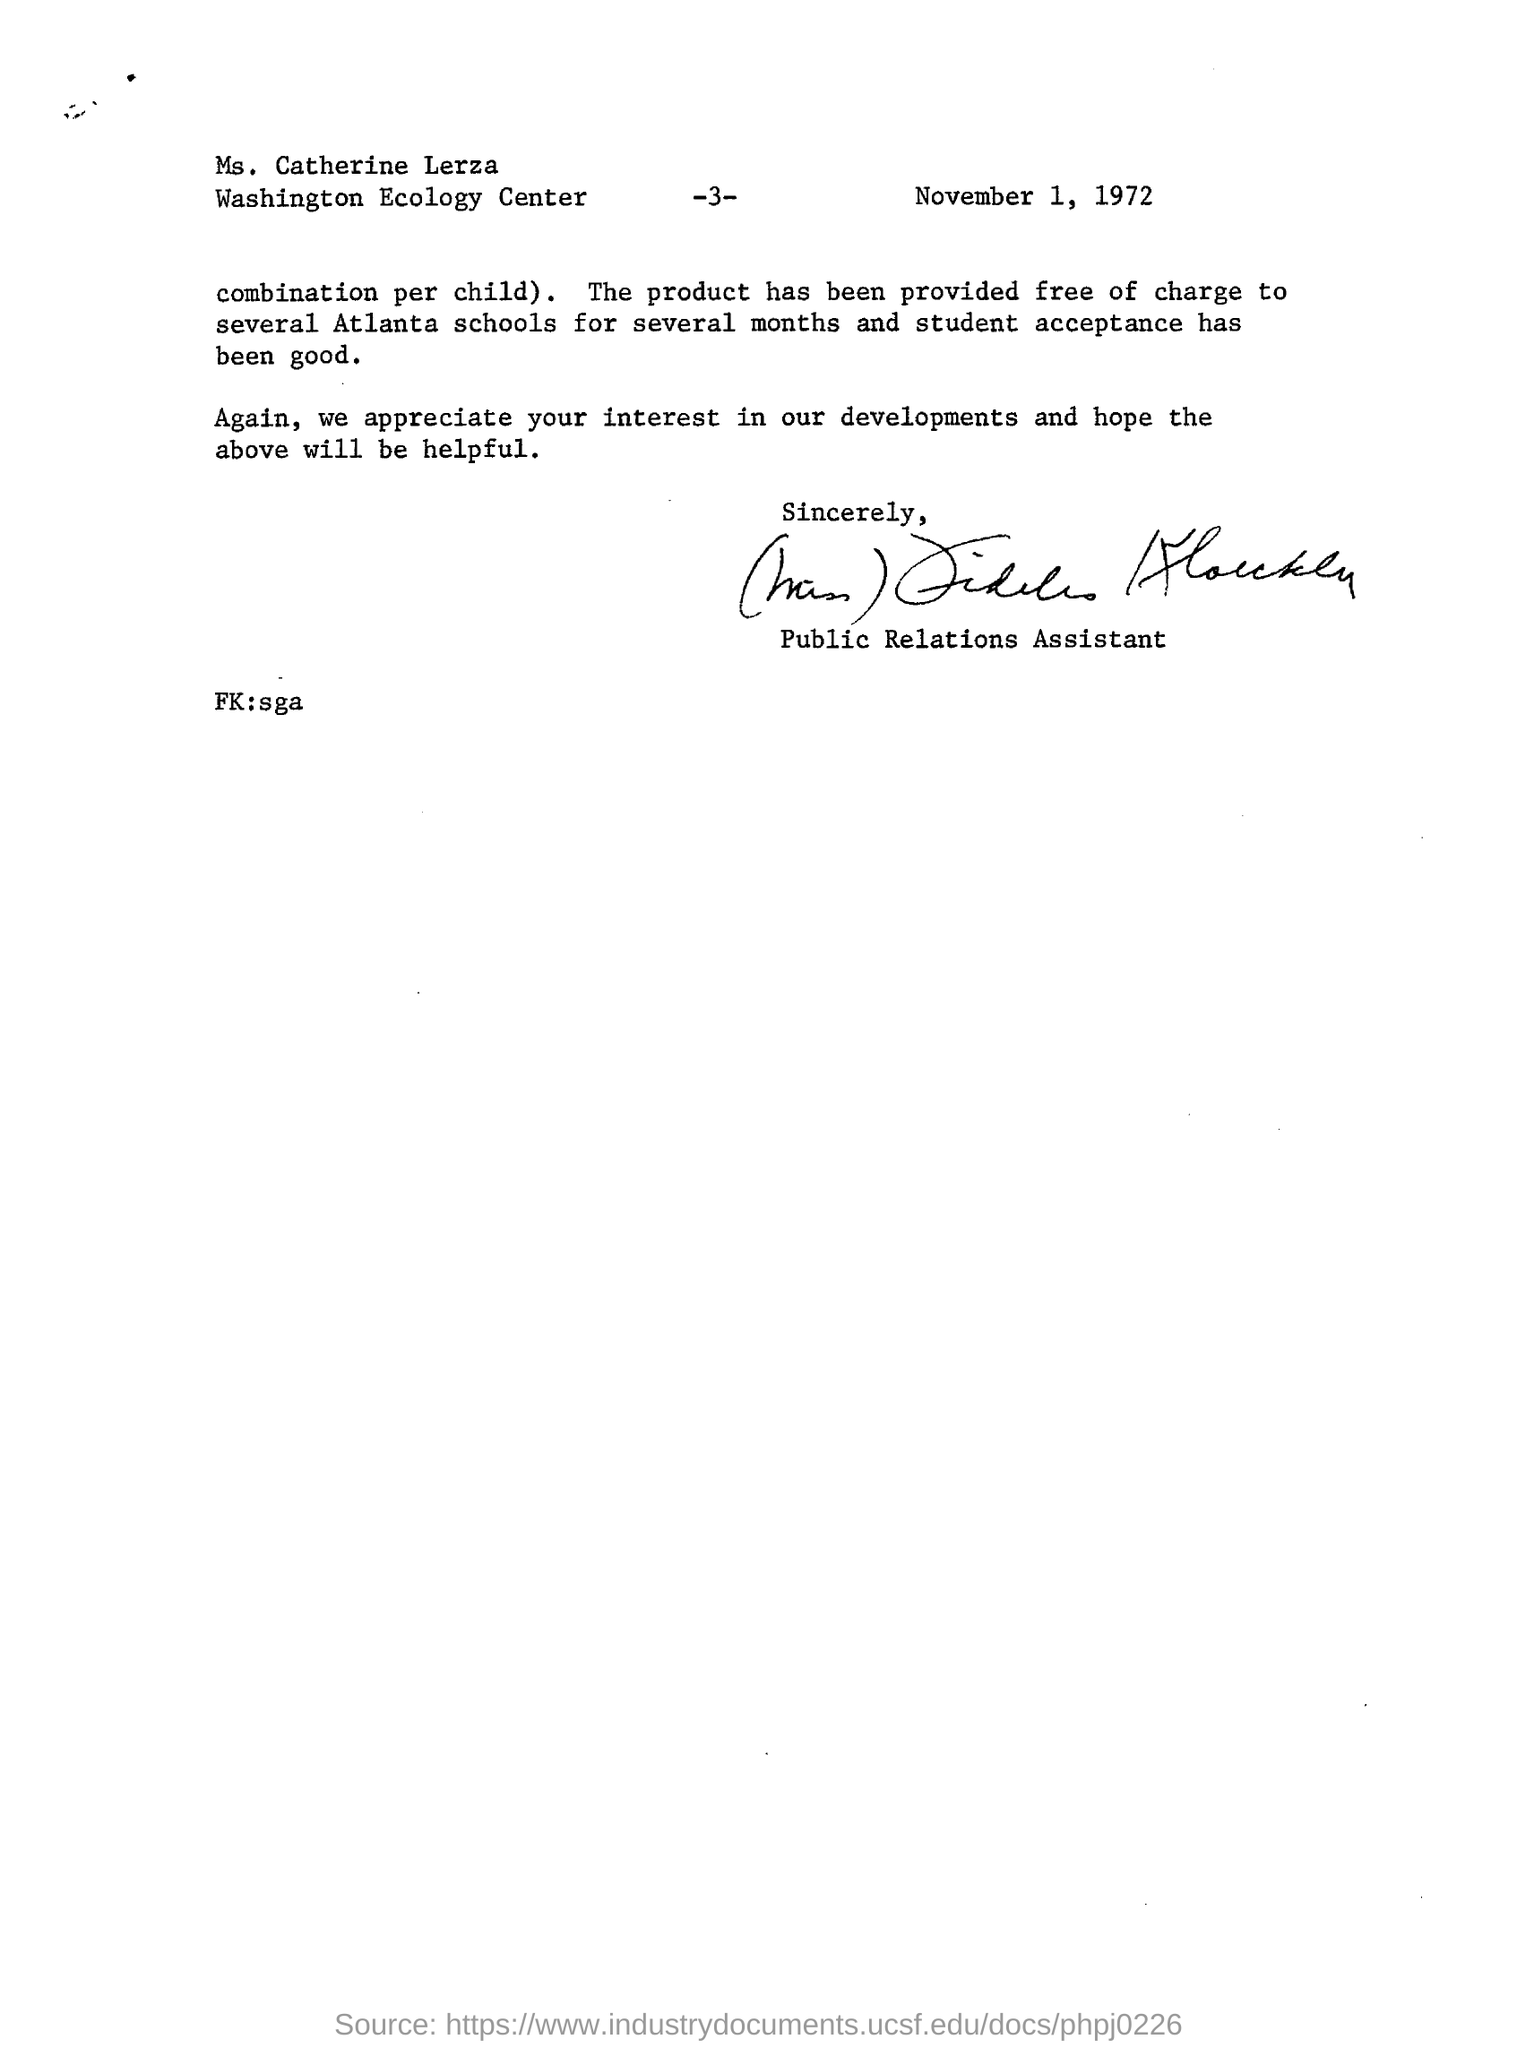What is the letter dated?
Your answer should be compact. November 1, 1972. What is the designation of the sender in this letter?
Make the answer very short. Public relations assistant. What is the page number mentioned in this letter?
Give a very brief answer. -3-. 